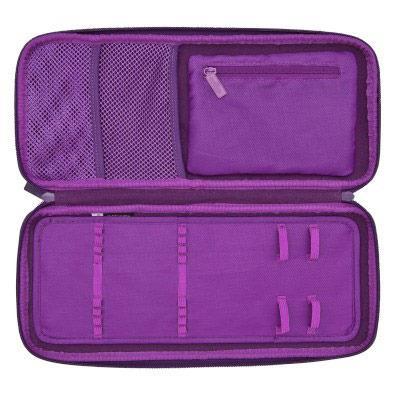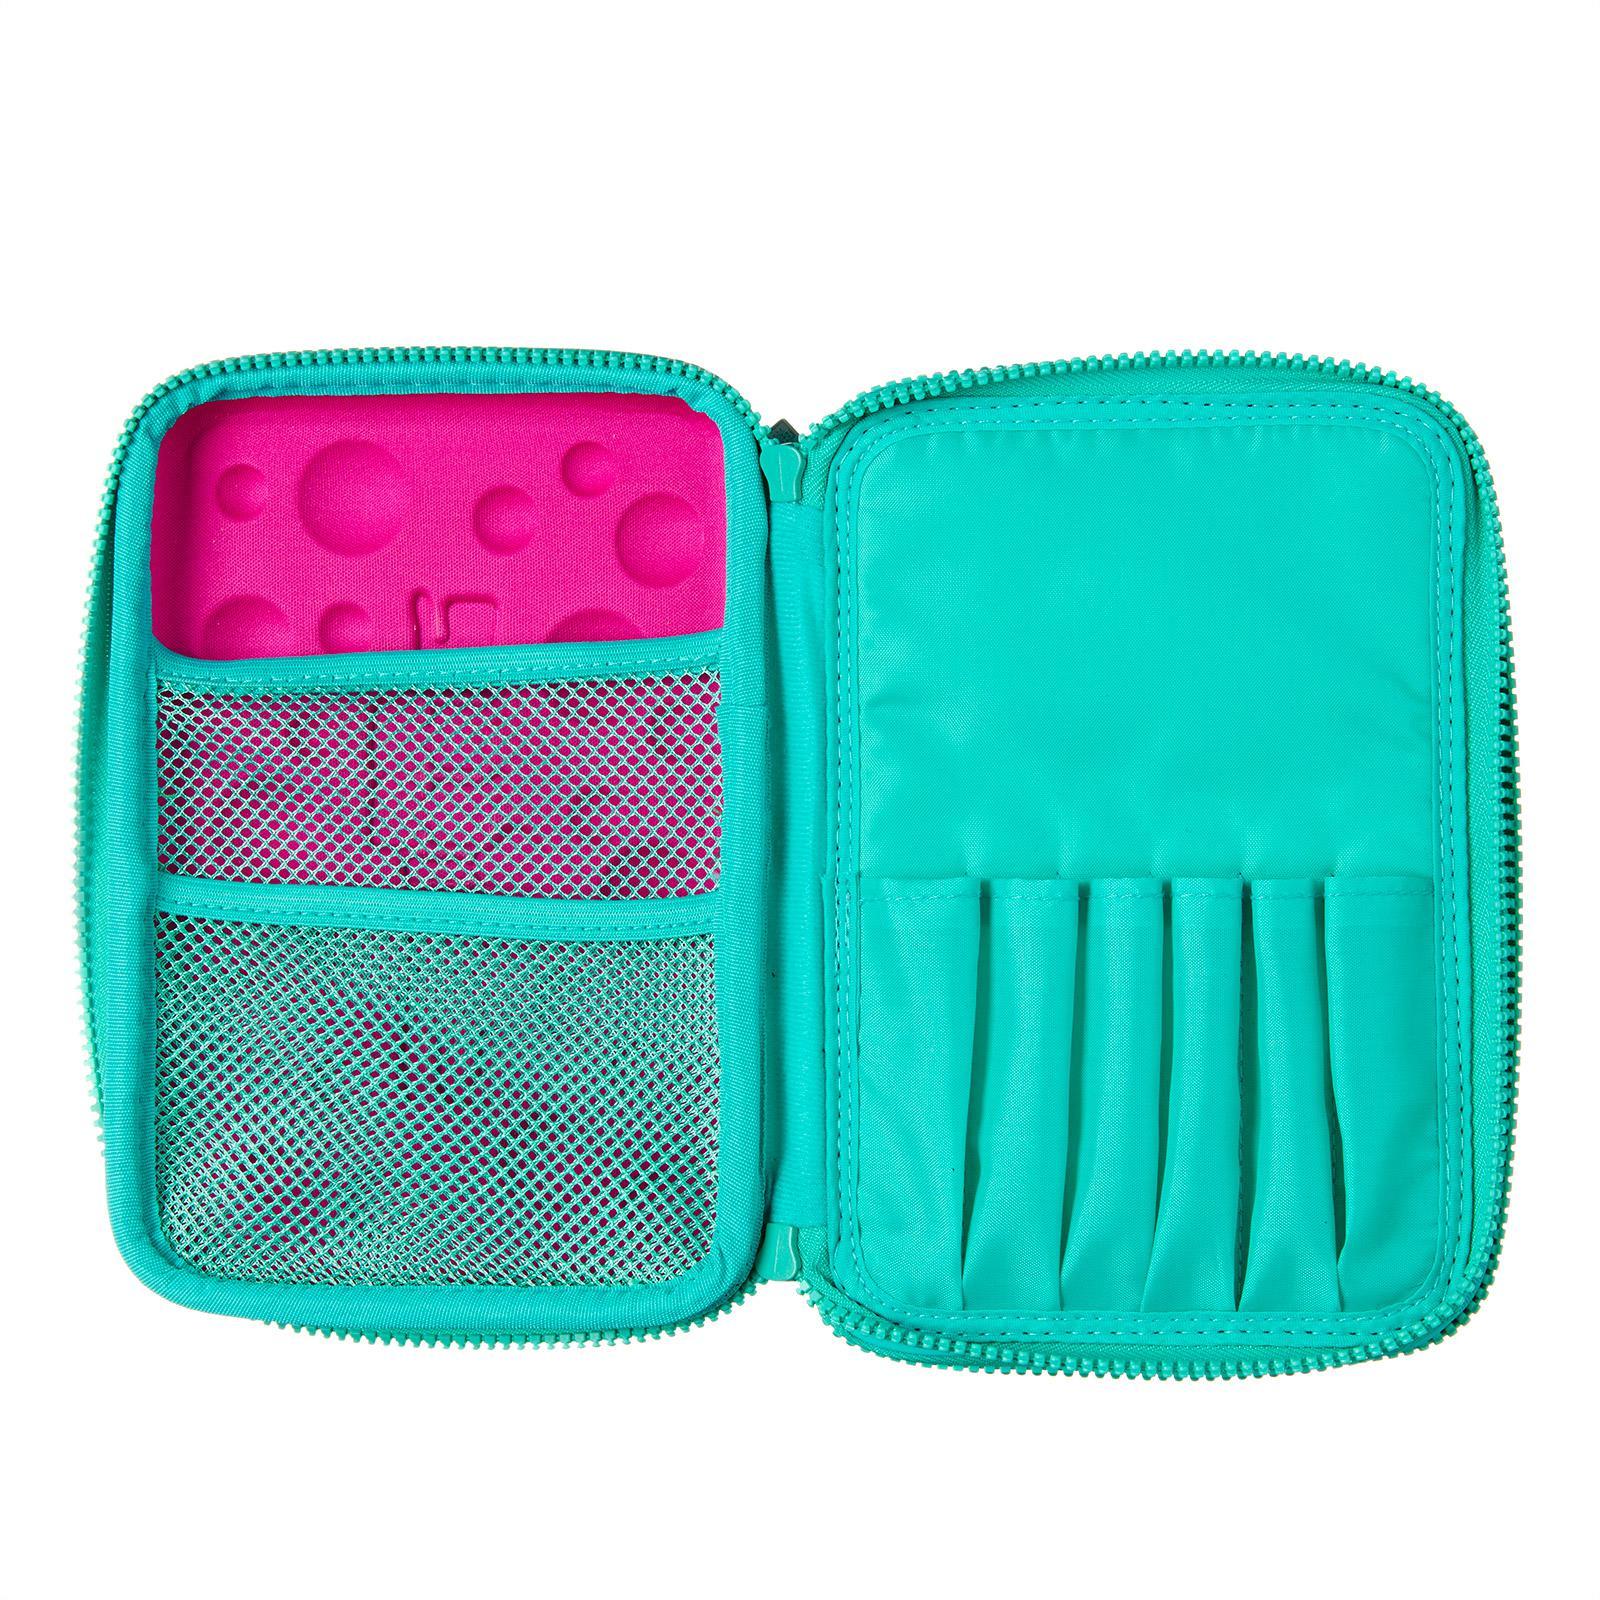The first image is the image on the left, the second image is the image on the right. Analyze the images presented: Is the assertion "There is at least one pencil case open with no visible stationery inside." valid? Answer yes or no. Yes. The first image is the image on the left, the second image is the image on the right. For the images shown, is this caption "There is a pink case in each of the photos, one that is closed and has blue dots on it and one of which is open to show the contents." true? Answer yes or no. No. 